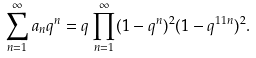<formula> <loc_0><loc_0><loc_500><loc_500>\sum _ { n = 1 } ^ { \infty } a _ { n } q ^ { n } = q \prod _ { n = 1 } ^ { \infty } ( 1 - q ^ { n } ) ^ { 2 } ( 1 - q ^ { 1 1 n } ) ^ { 2 } .</formula> 